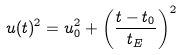Convert formula to latex. <formula><loc_0><loc_0><loc_500><loc_500>u ( t ) ^ { 2 } = u _ { 0 } ^ { 2 } + \left ( \frac { t - t _ { 0 } } { t _ { E } } \right ) ^ { 2 }</formula> 